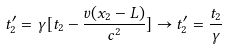Convert formula to latex. <formula><loc_0><loc_0><loc_500><loc_500>t ^ { \prime } _ { 2 } = \gamma [ t _ { 2 } - \frac { v ( x _ { 2 } - L ) } { c ^ { 2 } } ] \rightarrow t ^ { \prime } _ { 2 } = \frac { t _ { 2 } } { \gamma }</formula> 